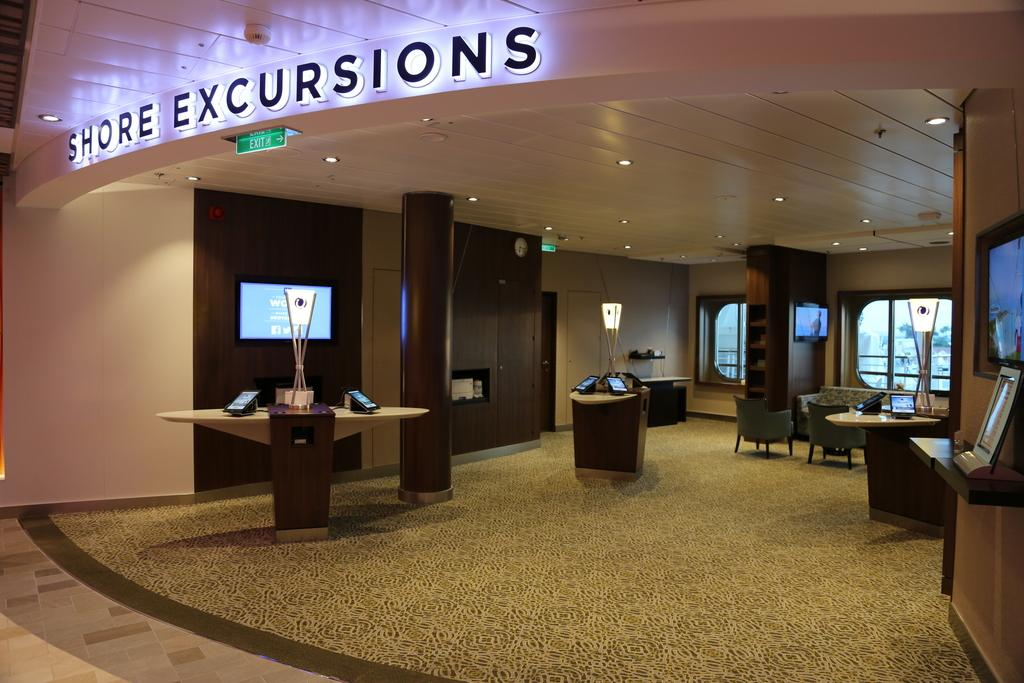What type of space is depicted in the image? The image appears to be a showroom. What can be seen in the middle of the room? There is a television in the middle of the room. What type of lighting is present in the room? There are ceiling lights at the top of the room. What type of furniture is on the right side of the room? There are sofa chairs and a table on the right side of the room. What month is it in the image? The image does not provide any information about the month or time of year. Can you see a basket in the image? There is no basket present in the image. 